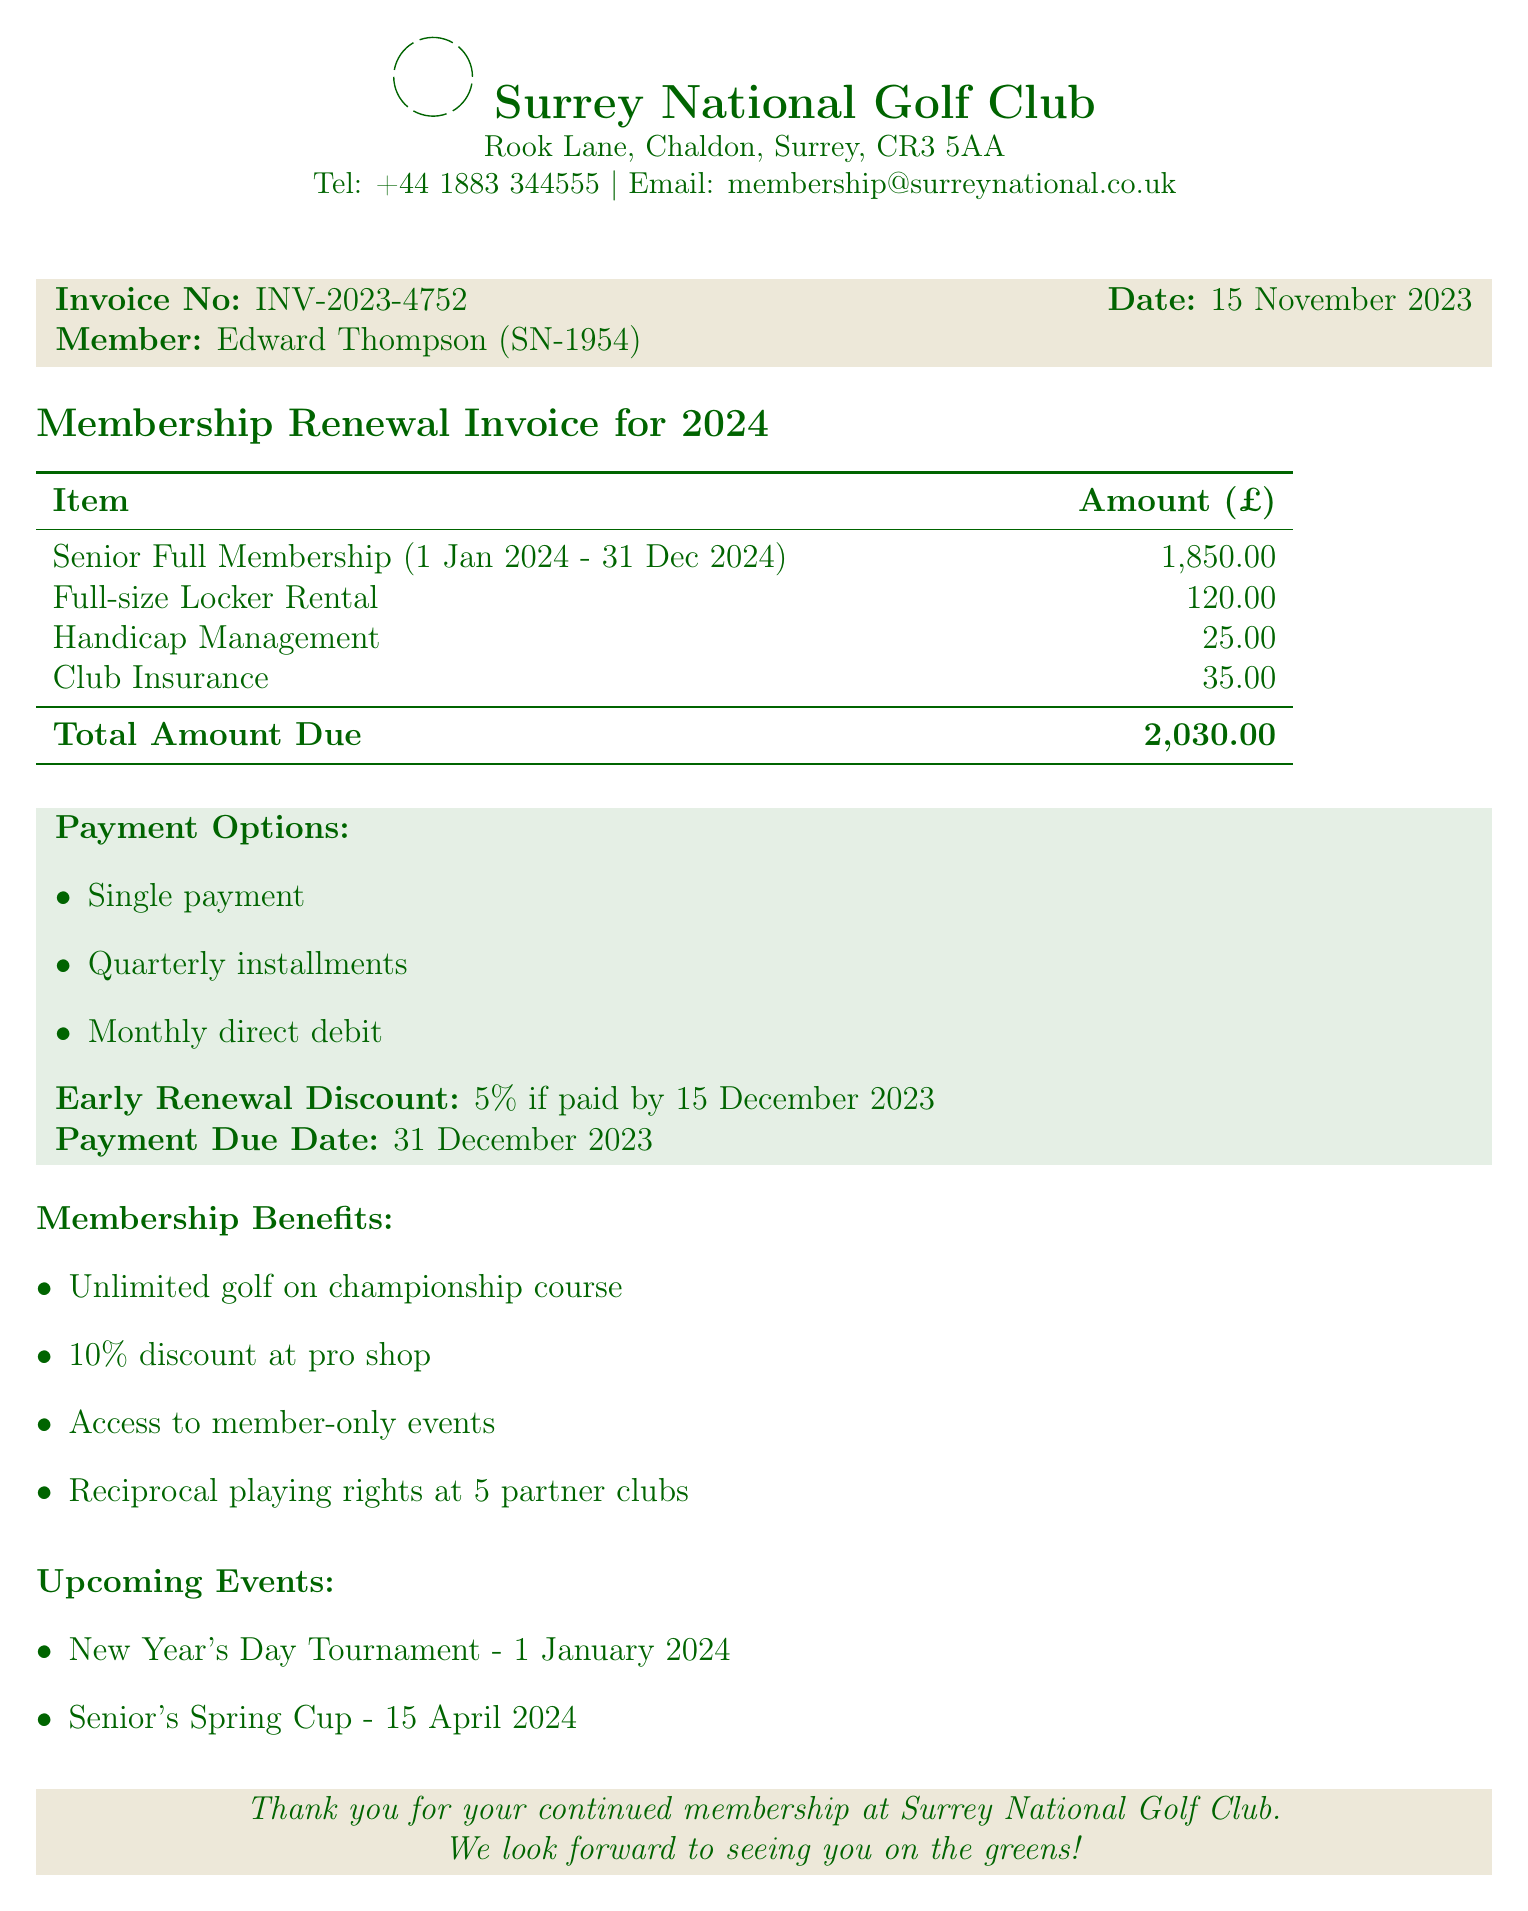What is the name of the golf club? The document states the name of the golf club is Surrey National Golf Club.
Answer: Surrey National Golf Club Who is the member listed in the invoice? The member's name is provided in the document as Edward Thompson.
Answer: Edward Thompson What is the total amount due for the membership renewal? The total amount due is explicitly mentioned in the document.
Answer: 2030.00 What is the membership type for Edward Thompson? The document specifies that Edward Thompson holds the title of Senior Full Member.
Answer: Senior Full Member What is the deadline for the early renewal discount? The document indicates that the early renewal discount deadline is December 15, 2023.
Answer: 2023-12-15 How much is the annual fee for locker rental? The locker rental fee is detailed in the document.
Answer: 120.00 What are the available payment options? The document lists three payment options that members can choose from.
Answer: Single payment, Quarterly installments, Monthly direct debit When does the membership period start? The document states the membership period will begin on January 1, 2024.
Answer: January 1, 2024 What events are upcoming for club members? The document lists upcoming events for members.
Answer: New Year's Day Tournament, Senior's Spring Cup 